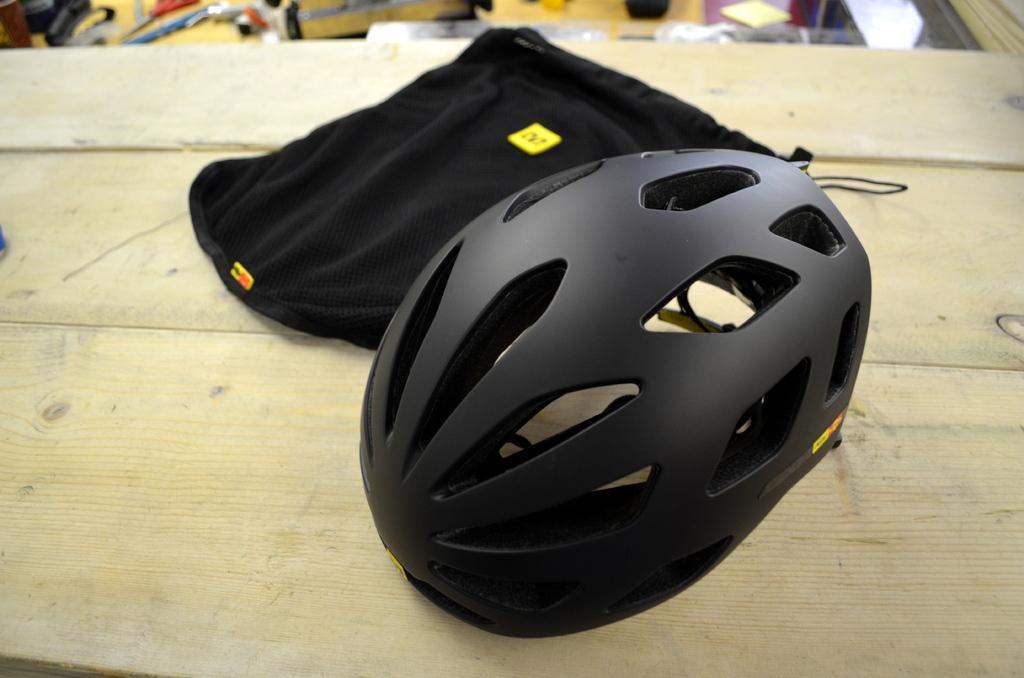How would you summarize this image in a sentence or two? In this picture there are objects which are black in colour in the center. In the background there are objects which are yellow and white in colour. 